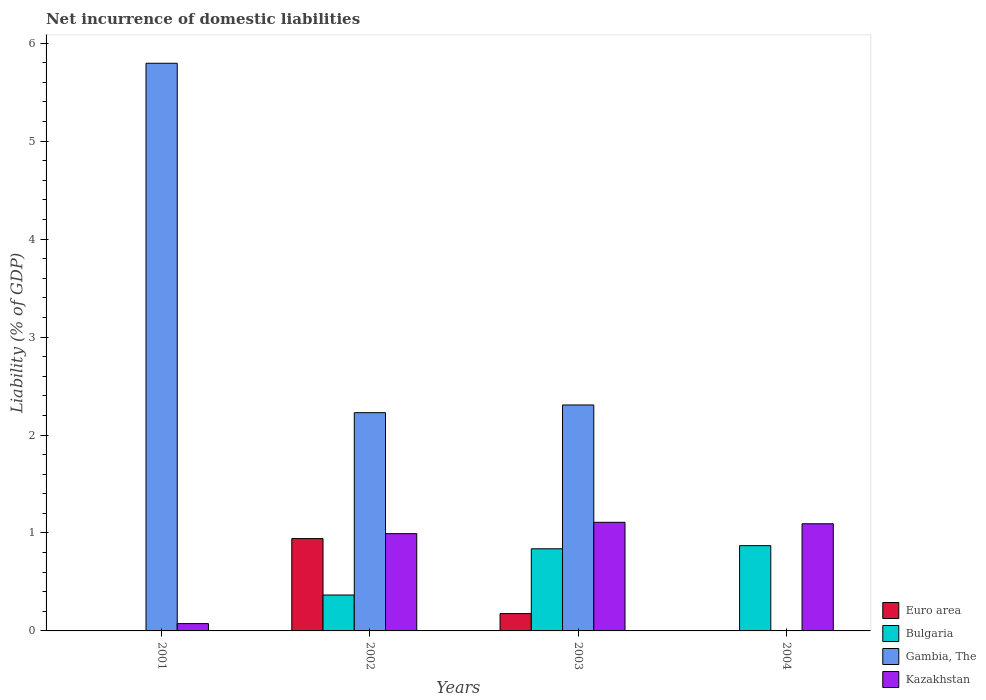How many different coloured bars are there?
Give a very brief answer. 4. Are the number of bars per tick equal to the number of legend labels?
Ensure brevity in your answer.  No. How many bars are there on the 3rd tick from the right?
Give a very brief answer. 4. What is the net incurrence of domestic liabilities in Bulgaria in 2001?
Give a very brief answer. 0. Across all years, what is the maximum net incurrence of domestic liabilities in Gambia, The?
Your response must be concise. 5.79. What is the total net incurrence of domestic liabilities in Euro area in the graph?
Offer a very short reply. 1.12. What is the difference between the net incurrence of domestic liabilities in Bulgaria in 2002 and that in 2004?
Offer a very short reply. -0.5. What is the difference between the net incurrence of domestic liabilities in Gambia, The in 2001 and the net incurrence of domestic liabilities in Kazakhstan in 2004?
Offer a terse response. 4.7. What is the average net incurrence of domestic liabilities in Euro area per year?
Offer a terse response. 0.28. In the year 2001, what is the difference between the net incurrence of domestic liabilities in Gambia, The and net incurrence of domestic liabilities in Kazakhstan?
Offer a very short reply. 5.72. What is the ratio of the net incurrence of domestic liabilities in Gambia, The in 2001 to that in 2002?
Provide a succinct answer. 2.6. What is the difference between the highest and the second highest net incurrence of domestic liabilities in Bulgaria?
Provide a short and direct response. 0.03. What is the difference between the highest and the lowest net incurrence of domestic liabilities in Gambia, The?
Ensure brevity in your answer.  5.79. How many bars are there?
Ensure brevity in your answer.  12. How many years are there in the graph?
Your answer should be compact. 4. Does the graph contain grids?
Ensure brevity in your answer.  No. Where does the legend appear in the graph?
Provide a short and direct response. Bottom right. How are the legend labels stacked?
Your response must be concise. Vertical. What is the title of the graph?
Your answer should be compact. Net incurrence of domestic liabilities. Does "Bolivia" appear as one of the legend labels in the graph?
Your response must be concise. No. What is the label or title of the Y-axis?
Your answer should be very brief. Liability (% of GDP). What is the Liability (% of GDP) of Euro area in 2001?
Give a very brief answer. 0. What is the Liability (% of GDP) in Bulgaria in 2001?
Offer a very short reply. 0. What is the Liability (% of GDP) of Gambia, The in 2001?
Your answer should be very brief. 5.79. What is the Liability (% of GDP) of Kazakhstan in 2001?
Provide a succinct answer. 0.07. What is the Liability (% of GDP) in Euro area in 2002?
Keep it short and to the point. 0.94. What is the Liability (% of GDP) in Bulgaria in 2002?
Your response must be concise. 0.37. What is the Liability (% of GDP) of Gambia, The in 2002?
Provide a succinct answer. 2.23. What is the Liability (% of GDP) of Kazakhstan in 2002?
Offer a very short reply. 0.99. What is the Liability (% of GDP) of Euro area in 2003?
Provide a short and direct response. 0.18. What is the Liability (% of GDP) of Bulgaria in 2003?
Provide a succinct answer. 0.84. What is the Liability (% of GDP) in Gambia, The in 2003?
Offer a terse response. 2.31. What is the Liability (% of GDP) in Kazakhstan in 2003?
Give a very brief answer. 1.11. What is the Liability (% of GDP) in Euro area in 2004?
Provide a short and direct response. 0. What is the Liability (% of GDP) of Bulgaria in 2004?
Give a very brief answer. 0.87. What is the Liability (% of GDP) in Kazakhstan in 2004?
Your answer should be compact. 1.09. Across all years, what is the maximum Liability (% of GDP) of Euro area?
Make the answer very short. 0.94. Across all years, what is the maximum Liability (% of GDP) of Bulgaria?
Your answer should be very brief. 0.87. Across all years, what is the maximum Liability (% of GDP) of Gambia, The?
Give a very brief answer. 5.79. Across all years, what is the maximum Liability (% of GDP) in Kazakhstan?
Your answer should be very brief. 1.11. Across all years, what is the minimum Liability (% of GDP) of Euro area?
Your answer should be very brief. 0. Across all years, what is the minimum Liability (% of GDP) in Bulgaria?
Provide a short and direct response. 0. Across all years, what is the minimum Liability (% of GDP) in Gambia, The?
Ensure brevity in your answer.  0. Across all years, what is the minimum Liability (% of GDP) in Kazakhstan?
Your response must be concise. 0.07. What is the total Liability (% of GDP) in Euro area in the graph?
Offer a terse response. 1.12. What is the total Liability (% of GDP) in Bulgaria in the graph?
Your answer should be compact. 2.08. What is the total Liability (% of GDP) of Gambia, The in the graph?
Make the answer very short. 10.33. What is the total Liability (% of GDP) of Kazakhstan in the graph?
Provide a succinct answer. 3.27. What is the difference between the Liability (% of GDP) of Gambia, The in 2001 and that in 2002?
Make the answer very short. 3.57. What is the difference between the Liability (% of GDP) of Kazakhstan in 2001 and that in 2002?
Give a very brief answer. -0.92. What is the difference between the Liability (% of GDP) of Gambia, The in 2001 and that in 2003?
Provide a short and direct response. 3.49. What is the difference between the Liability (% of GDP) in Kazakhstan in 2001 and that in 2003?
Your answer should be compact. -1.03. What is the difference between the Liability (% of GDP) of Kazakhstan in 2001 and that in 2004?
Offer a terse response. -1.02. What is the difference between the Liability (% of GDP) in Euro area in 2002 and that in 2003?
Keep it short and to the point. 0.77. What is the difference between the Liability (% of GDP) in Bulgaria in 2002 and that in 2003?
Keep it short and to the point. -0.47. What is the difference between the Liability (% of GDP) in Gambia, The in 2002 and that in 2003?
Give a very brief answer. -0.08. What is the difference between the Liability (% of GDP) in Kazakhstan in 2002 and that in 2003?
Keep it short and to the point. -0.12. What is the difference between the Liability (% of GDP) in Bulgaria in 2002 and that in 2004?
Offer a terse response. -0.5. What is the difference between the Liability (% of GDP) of Kazakhstan in 2002 and that in 2004?
Your answer should be very brief. -0.1. What is the difference between the Liability (% of GDP) of Bulgaria in 2003 and that in 2004?
Make the answer very short. -0.03. What is the difference between the Liability (% of GDP) of Kazakhstan in 2003 and that in 2004?
Offer a very short reply. 0.01. What is the difference between the Liability (% of GDP) of Gambia, The in 2001 and the Liability (% of GDP) of Kazakhstan in 2002?
Your answer should be compact. 4.8. What is the difference between the Liability (% of GDP) in Gambia, The in 2001 and the Liability (% of GDP) in Kazakhstan in 2003?
Provide a succinct answer. 4.69. What is the difference between the Liability (% of GDP) in Gambia, The in 2001 and the Liability (% of GDP) in Kazakhstan in 2004?
Make the answer very short. 4.7. What is the difference between the Liability (% of GDP) of Euro area in 2002 and the Liability (% of GDP) of Bulgaria in 2003?
Your response must be concise. 0.1. What is the difference between the Liability (% of GDP) in Euro area in 2002 and the Liability (% of GDP) in Gambia, The in 2003?
Offer a very short reply. -1.36. What is the difference between the Liability (% of GDP) in Euro area in 2002 and the Liability (% of GDP) in Kazakhstan in 2003?
Make the answer very short. -0.17. What is the difference between the Liability (% of GDP) in Bulgaria in 2002 and the Liability (% of GDP) in Gambia, The in 2003?
Your answer should be compact. -1.94. What is the difference between the Liability (% of GDP) in Bulgaria in 2002 and the Liability (% of GDP) in Kazakhstan in 2003?
Offer a terse response. -0.74. What is the difference between the Liability (% of GDP) of Gambia, The in 2002 and the Liability (% of GDP) of Kazakhstan in 2003?
Provide a short and direct response. 1.12. What is the difference between the Liability (% of GDP) in Euro area in 2002 and the Liability (% of GDP) in Bulgaria in 2004?
Provide a succinct answer. 0.07. What is the difference between the Liability (% of GDP) in Euro area in 2002 and the Liability (% of GDP) in Kazakhstan in 2004?
Give a very brief answer. -0.15. What is the difference between the Liability (% of GDP) of Bulgaria in 2002 and the Liability (% of GDP) of Kazakhstan in 2004?
Provide a succinct answer. -0.73. What is the difference between the Liability (% of GDP) in Gambia, The in 2002 and the Liability (% of GDP) in Kazakhstan in 2004?
Offer a terse response. 1.13. What is the difference between the Liability (% of GDP) of Euro area in 2003 and the Liability (% of GDP) of Bulgaria in 2004?
Provide a succinct answer. -0.69. What is the difference between the Liability (% of GDP) of Euro area in 2003 and the Liability (% of GDP) of Kazakhstan in 2004?
Your response must be concise. -0.92. What is the difference between the Liability (% of GDP) in Bulgaria in 2003 and the Liability (% of GDP) in Kazakhstan in 2004?
Ensure brevity in your answer.  -0.26. What is the difference between the Liability (% of GDP) in Gambia, The in 2003 and the Liability (% of GDP) in Kazakhstan in 2004?
Your answer should be very brief. 1.21. What is the average Liability (% of GDP) in Euro area per year?
Offer a terse response. 0.28. What is the average Liability (% of GDP) of Bulgaria per year?
Offer a very short reply. 0.52. What is the average Liability (% of GDP) of Gambia, The per year?
Make the answer very short. 2.58. What is the average Liability (% of GDP) in Kazakhstan per year?
Your answer should be very brief. 0.82. In the year 2001, what is the difference between the Liability (% of GDP) of Gambia, The and Liability (% of GDP) of Kazakhstan?
Provide a succinct answer. 5.72. In the year 2002, what is the difference between the Liability (% of GDP) in Euro area and Liability (% of GDP) in Bulgaria?
Offer a terse response. 0.58. In the year 2002, what is the difference between the Liability (% of GDP) in Euro area and Liability (% of GDP) in Gambia, The?
Offer a very short reply. -1.29. In the year 2002, what is the difference between the Liability (% of GDP) in Euro area and Liability (% of GDP) in Kazakhstan?
Keep it short and to the point. -0.05. In the year 2002, what is the difference between the Liability (% of GDP) in Bulgaria and Liability (% of GDP) in Gambia, The?
Offer a terse response. -1.86. In the year 2002, what is the difference between the Liability (% of GDP) in Bulgaria and Liability (% of GDP) in Kazakhstan?
Offer a terse response. -0.63. In the year 2002, what is the difference between the Liability (% of GDP) of Gambia, The and Liability (% of GDP) of Kazakhstan?
Give a very brief answer. 1.24. In the year 2003, what is the difference between the Liability (% of GDP) in Euro area and Liability (% of GDP) in Bulgaria?
Give a very brief answer. -0.66. In the year 2003, what is the difference between the Liability (% of GDP) in Euro area and Liability (% of GDP) in Gambia, The?
Make the answer very short. -2.13. In the year 2003, what is the difference between the Liability (% of GDP) of Euro area and Liability (% of GDP) of Kazakhstan?
Offer a terse response. -0.93. In the year 2003, what is the difference between the Liability (% of GDP) in Bulgaria and Liability (% of GDP) in Gambia, The?
Ensure brevity in your answer.  -1.47. In the year 2003, what is the difference between the Liability (% of GDP) in Bulgaria and Liability (% of GDP) in Kazakhstan?
Offer a very short reply. -0.27. In the year 2003, what is the difference between the Liability (% of GDP) of Gambia, The and Liability (% of GDP) of Kazakhstan?
Keep it short and to the point. 1.2. In the year 2004, what is the difference between the Liability (% of GDP) in Bulgaria and Liability (% of GDP) in Kazakhstan?
Offer a very short reply. -0.22. What is the ratio of the Liability (% of GDP) of Gambia, The in 2001 to that in 2002?
Provide a short and direct response. 2.6. What is the ratio of the Liability (% of GDP) of Kazakhstan in 2001 to that in 2002?
Keep it short and to the point. 0.08. What is the ratio of the Liability (% of GDP) in Gambia, The in 2001 to that in 2003?
Your response must be concise. 2.51. What is the ratio of the Liability (% of GDP) in Kazakhstan in 2001 to that in 2003?
Your answer should be very brief. 0.07. What is the ratio of the Liability (% of GDP) of Kazakhstan in 2001 to that in 2004?
Provide a succinct answer. 0.07. What is the ratio of the Liability (% of GDP) of Euro area in 2002 to that in 2003?
Make the answer very short. 5.33. What is the ratio of the Liability (% of GDP) in Bulgaria in 2002 to that in 2003?
Make the answer very short. 0.44. What is the ratio of the Liability (% of GDP) of Kazakhstan in 2002 to that in 2003?
Provide a succinct answer. 0.9. What is the ratio of the Liability (% of GDP) in Bulgaria in 2002 to that in 2004?
Provide a short and direct response. 0.42. What is the ratio of the Liability (% of GDP) of Kazakhstan in 2002 to that in 2004?
Your answer should be very brief. 0.91. What is the ratio of the Liability (% of GDP) of Bulgaria in 2003 to that in 2004?
Your answer should be compact. 0.96. What is the ratio of the Liability (% of GDP) of Kazakhstan in 2003 to that in 2004?
Give a very brief answer. 1.01. What is the difference between the highest and the second highest Liability (% of GDP) of Bulgaria?
Offer a terse response. 0.03. What is the difference between the highest and the second highest Liability (% of GDP) in Gambia, The?
Your answer should be compact. 3.49. What is the difference between the highest and the second highest Liability (% of GDP) in Kazakhstan?
Your response must be concise. 0.01. What is the difference between the highest and the lowest Liability (% of GDP) of Euro area?
Your response must be concise. 0.94. What is the difference between the highest and the lowest Liability (% of GDP) of Bulgaria?
Make the answer very short. 0.87. What is the difference between the highest and the lowest Liability (% of GDP) of Gambia, The?
Ensure brevity in your answer.  5.79. What is the difference between the highest and the lowest Liability (% of GDP) in Kazakhstan?
Provide a short and direct response. 1.03. 